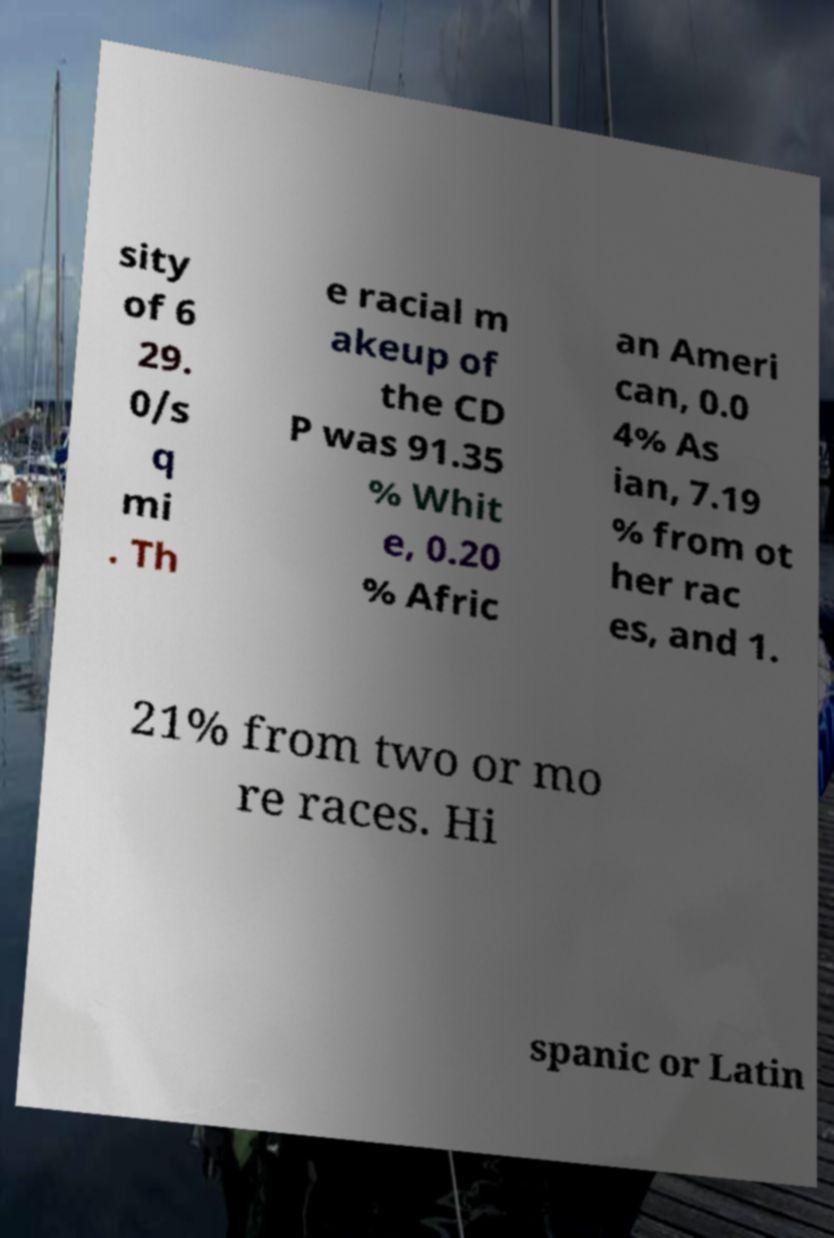Please identify and transcribe the text found in this image. sity of 6 29. 0/s q mi . Th e racial m akeup of the CD P was 91.35 % Whit e, 0.20 % Afric an Ameri can, 0.0 4% As ian, 7.19 % from ot her rac es, and 1. 21% from two or mo re races. Hi spanic or Latin 